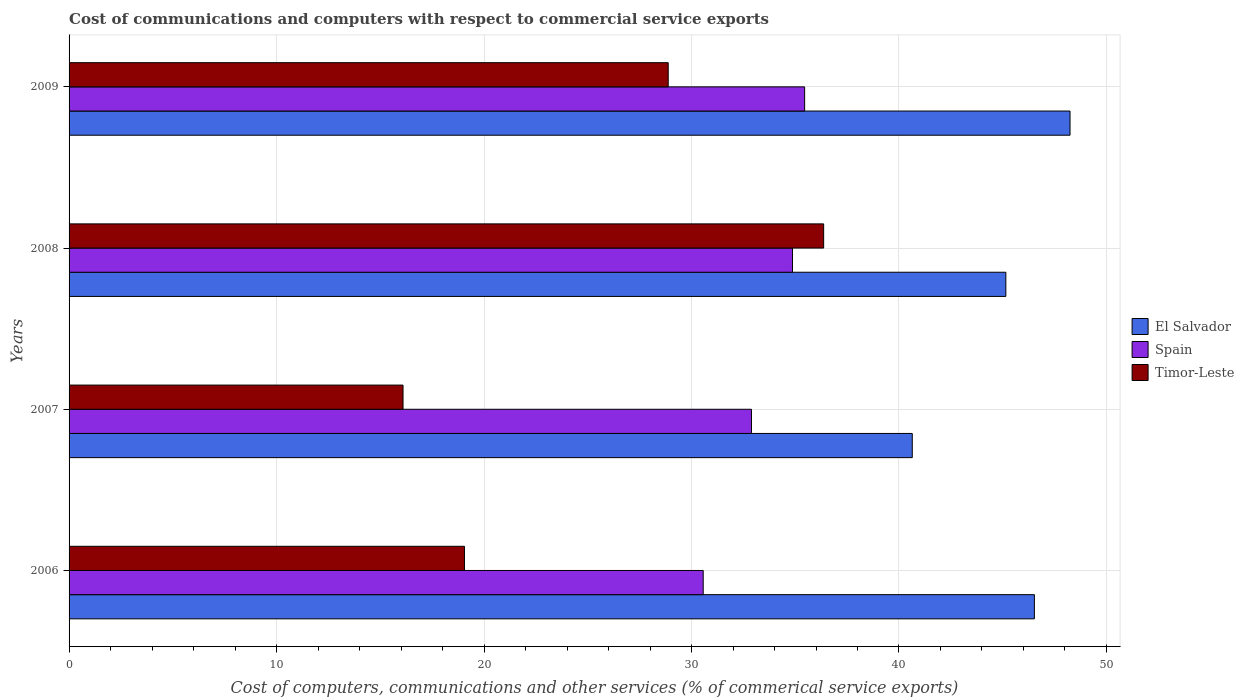Are the number of bars per tick equal to the number of legend labels?
Offer a terse response. Yes. How many bars are there on the 4th tick from the bottom?
Your response must be concise. 3. In how many cases, is the number of bars for a given year not equal to the number of legend labels?
Provide a succinct answer. 0. What is the cost of communications and computers in Spain in 2008?
Provide a short and direct response. 34.87. Across all years, what is the maximum cost of communications and computers in El Salvador?
Offer a very short reply. 48.24. Across all years, what is the minimum cost of communications and computers in Spain?
Offer a terse response. 30.56. In which year was the cost of communications and computers in El Salvador maximum?
Offer a terse response. 2009. In which year was the cost of communications and computers in El Salvador minimum?
Make the answer very short. 2007. What is the total cost of communications and computers in El Salvador in the graph?
Keep it short and to the point. 180.56. What is the difference between the cost of communications and computers in Timor-Leste in 2008 and that in 2009?
Your answer should be very brief. 7.49. What is the difference between the cost of communications and computers in Spain in 2006 and the cost of communications and computers in Timor-Leste in 2007?
Offer a very short reply. 14.47. What is the average cost of communications and computers in El Salvador per year?
Your answer should be very brief. 45.14. In the year 2006, what is the difference between the cost of communications and computers in Spain and cost of communications and computers in Timor-Leste?
Offer a terse response. 11.51. What is the ratio of the cost of communications and computers in Timor-Leste in 2006 to that in 2007?
Give a very brief answer. 1.18. Is the cost of communications and computers in Spain in 2007 less than that in 2008?
Offer a terse response. Yes. Is the difference between the cost of communications and computers in Spain in 2006 and 2008 greater than the difference between the cost of communications and computers in Timor-Leste in 2006 and 2008?
Give a very brief answer. Yes. What is the difference between the highest and the second highest cost of communications and computers in El Salvador?
Provide a short and direct response. 1.72. What is the difference between the highest and the lowest cost of communications and computers in Timor-Leste?
Provide a succinct answer. 20.27. In how many years, is the cost of communications and computers in Spain greater than the average cost of communications and computers in Spain taken over all years?
Provide a succinct answer. 2. What does the 1st bar from the top in 2007 represents?
Provide a succinct answer. Timor-Leste. What does the 1st bar from the bottom in 2009 represents?
Provide a short and direct response. El Salvador. How many bars are there?
Your response must be concise. 12. Are all the bars in the graph horizontal?
Your answer should be compact. Yes. How many years are there in the graph?
Your response must be concise. 4. What is the difference between two consecutive major ticks on the X-axis?
Ensure brevity in your answer.  10. Where does the legend appear in the graph?
Ensure brevity in your answer.  Center right. How many legend labels are there?
Offer a very short reply. 3. What is the title of the graph?
Offer a terse response. Cost of communications and computers with respect to commercial service exports. What is the label or title of the X-axis?
Give a very brief answer. Cost of computers, communications and other services (% of commerical service exports). What is the label or title of the Y-axis?
Keep it short and to the point. Years. What is the Cost of computers, communications and other services (% of commerical service exports) of El Salvador in 2006?
Your answer should be compact. 46.53. What is the Cost of computers, communications and other services (% of commerical service exports) in Spain in 2006?
Your answer should be compact. 30.56. What is the Cost of computers, communications and other services (% of commerical service exports) of Timor-Leste in 2006?
Keep it short and to the point. 19.06. What is the Cost of computers, communications and other services (% of commerical service exports) of El Salvador in 2007?
Keep it short and to the point. 40.64. What is the Cost of computers, communications and other services (% of commerical service exports) in Spain in 2007?
Your answer should be compact. 32.89. What is the Cost of computers, communications and other services (% of commerical service exports) of Timor-Leste in 2007?
Your answer should be very brief. 16.1. What is the Cost of computers, communications and other services (% of commerical service exports) of El Salvador in 2008?
Your answer should be very brief. 45.15. What is the Cost of computers, communications and other services (% of commerical service exports) in Spain in 2008?
Make the answer very short. 34.87. What is the Cost of computers, communications and other services (% of commerical service exports) of Timor-Leste in 2008?
Offer a very short reply. 36.37. What is the Cost of computers, communications and other services (% of commerical service exports) in El Salvador in 2009?
Offer a terse response. 48.24. What is the Cost of computers, communications and other services (% of commerical service exports) in Spain in 2009?
Provide a succinct answer. 35.45. What is the Cost of computers, communications and other services (% of commerical service exports) of Timor-Leste in 2009?
Your answer should be compact. 28.88. Across all years, what is the maximum Cost of computers, communications and other services (% of commerical service exports) of El Salvador?
Give a very brief answer. 48.24. Across all years, what is the maximum Cost of computers, communications and other services (% of commerical service exports) in Spain?
Make the answer very short. 35.45. Across all years, what is the maximum Cost of computers, communications and other services (% of commerical service exports) of Timor-Leste?
Offer a very short reply. 36.37. Across all years, what is the minimum Cost of computers, communications and other services (% of commerical service exports) in El Salvador?
Your answer should be very brief. 40.64. Across all years, what is the minimum Cost of computers, communications and other services (% of commerical service exports) in Spain?
Provide a succinct answer. 30.56. Across all years, what is the minimum Cost of computers, communications and other services (% of commerical service exports) in Timor-Leste?
Offer a terse response. 16.1. What is the total Cost of computers, communications and other services (% of commerical service exports) of El Salvador in the graph?
Ensure brevity in your answer.  180.56. What is the total Cost of computers, communications and other services (% of commerical service exports) of Spain in the graph?
Your answer should be compact. 133.77. What is the total Cost of computers, communications and other services (% of commerical service exports) in Timor-Leste in the graph?
Provide a short and direct response. 100.4. What is the difference between the Cost of computers, communications and other services (% of commerical service exports) of El Salvador in 2006 and that in 2007?
Your response must be concise. 5.89. What is the difference between the Cost of computers, communications and other services (% of commerical service exports) in Spain in 2006 and that in 2007?
Your response must be concise. -2.33. What is the difference between the Cost of computers, communications and other services (% of commerical service exports) of Timor-Leste in 2006 and that in 2007?
Your answer should be very brief. 2.96. What is the difference between the Cost of computers, communications and other services (% of commerical service exports) in El Salvador in 2006 and that in 2008?
Make the answer very short. 1.38. What is the difference between the Cost of computers, communications and other services (% of commerical service exports) of Spain in 2006 and that in 2008?
Provide a succinct answer. -4.3. What is the difference between the Cost of computers, communications and other services (% of commerical service exports) of Timor-Leste in 2006 and that in 2008?
Your answer should be compact. -17.31. What is the difference between the Cost of computers, communications and other services (% of commerical service exports) in El Salvador in 2006 and that in 2009?
Ensure brevity in your answer.  -1.72. What is the difference between the Cost of computers, communications and other services (% of commerical service exports) of Spain in 2006 and that in 2009?
Make the answer very short. -4.89. What is the difference between the Cost of computers, communications and other services (% of commerical service exports) in Timor-Leste in 2006 and that in 2009?
Provide a short and direct response. -9.82. What is the difference between the Cost of computers, communications and other services (% of commerical service exports) of El Salvador in 2007 and that in 2008?
Your answer should be compact. -4.51. What is the difference between the Cost of computers, communications and other services (% of commerical service exports) in Spain in 2007 and that in 2008?
Your response must be concise. -1.98. What is the difference between the Cost of computers, communications and other services (% of commerical service exports) of Timor-Leste in 2007 and that in 2008?
Make the answer very short. -20.27. What is the difference between the Cost of computers, communications and other services (% of commerical service exports) in El Salvador in 2007 and that in 2009?
Offer a terse response. -7.6. What is the difference between the Cost of computers, communications and other services (% of commerical service exports) in Spain in 2007 and that in 2009?
Offer a terse response. -2.56. What is the difference between the Cost of computers, communications and other services (% of commerical service exports) in Timor-Leste in 2007 and that in 2009?
Your answer should be compact. -12.78. What is the difference between the Cost of computers, communications and other services (% of commerical service exports) of El Salvador in 2008 and that in 2009?
Make the answer very short. -3.09. What is the difference between the Cost of computers, communications and other services (% of commerical service exports) of Spain in 2008 and that in 2009?
Give a very brief answer. -0.59. What is the difference between the Cost of computers, communications and other services (% of commerical service exports) of Timor-Leste in 2008 and that in 2009?
Provide a succinct answer. 7.49. What is the difference between the Cost of computers, communications and other services (% of commerical service exports) of El Salvador in 2006 and the Cost of computers, communications and other services (% of commerical service exports) of Spain in 2007?
Give a very brief answer. 13.64. What is the difference between the Cost of computers, communications and other services (% of commerical service exports) of El Salvador in 2006 and the Cost of computers, communications and other services (% of commerical service exports) of Timor-Leste in 2007?
Offer a terse response. 30.43. What is the difference between the Cost of computers, communications and other services (% of commerical service exports) of Spain in 2006 and the Cost of computers, communications and other services (% of commerical service exports) of Timor-Leste in 2007?
Your answer should be compact. 14.47. What is the difference between the Cost of computers, communications and other services (% of commerical service exports) in El Salvador in 2006 and the Cost of computers, communications and other services (% of commerical service exports) in Spain in 2008?
Offer a terse response. 11.66. What is the difference between the Cost of computers, communications and other services (% of commerical service exports) of El Salvador in 2006 and the Cost of computers, communications and other services (% of commerical service exports) of Timor-Leste in 2008?
Offer a terse response. 10.16. What is the difference between the Cost of computers, communications and other services (% of commerical service exports) in Spain in 2006 and the Cost of computers, communications and other services (% of commerical service exports) in Timor-Leste in 2008?
Your answer should be very brief. -5.81. What is the difference between the Cost of computers, communications and other services (% of commerical service exports) of El Salvador in 2006 and the Cost of computers, communications and other services (% of commerical service exports) of Spain in 2009?
Give a very brief answer. 11.07. What is the difference between the Cost of computers, communications and other services (% of commerical service exports) of El Salvador in 2006 and the Cost of computers, communications and other services (% of commerical service exports) of Timor-Leste in 2009?
Give a very brief answer. 17.65. What is the difference between the Cost of computers, communications and other services (% of commerical service exports) in Spain in 2006 and the Cost of computers, communications and other services (% of commerical service exports) in Timor-Leste in 2009?
Your answer should be compact. 1.69. What is the difference between the Cost of computers, communications and other services (% of commerical service exports) of El Salvador in 2007 and the Cost of computers, communications and other services (% of commerical service exports) of Spain in 2008?
Your answer should be compact. 5.77. What is the difference between the Cost of computers, communications and other services (% of commerical service exports) of El Salvador in 2007 and the Cost of computers, communications and other services (% of commerical service exports) of Timor-Leste in 2008?
Your response must be concise. 4.27. What is the difference between the Cost of computers, communications and other services (% of commerical service exports) of Spain in 2007 and the Cost of computers, communications and other services (% of commerical service exports) of Timor-Leste in 2008?
Ensure brevity in your answer.  -3.48. What is the difference between the Cost of computers, communications and other services (% of commerical service exports) in El Salvador in 2007 and the Cost of computers, communications and other services (% of commerical service exports) in Spain in 2009?
Offer a terse response. 5.19. What is the difference between the Cost of computers, communications and other services (% of commerical service exports) in El Salvador in 2007 and the Cost of computers, communications and other services (% of commerical service exports) in Timor-Leste in 2009?
Your answer should be compact. 11.76. What is the difference between the Cost of computers, communications and other services (% of commerical service exports) of Spain in 2007 and the Cost of computers, communications and other services (% of commerical service exports) of Timor-Leste in 2009?
Provide a short and direct response. 4.01. What is the difference between the Cost of computers, communications and other services (% of commerical service exports) in El Salvador in 2008 and the Cost of computers, communications and other services (% of commerical service exports) in Spain in 2009?
Give a very brief answer. 9.7. What is the difference between the Cost of computers, communications and other services (% of commerical service exports) of El Salvador in 2008 and the Cost of computers, communications and other services (% of commerical service exports) of Timor-Leste in 2009?
Your answer should be compact. 16.27. What is the difference between the Cost of computers, communications and other services (% of commerical service exports) in Spain in 2008 and the Cost of computers, communications and other services (% of commerical service exports) in Timor-Leste in 2009?
Offer a terse response. 5.99. What is the average Cost of computers, communications and other services (% of commerical service exports) of El Salvador per year?
Give a very brief answer. 45.14. What is the average Cost of computers, communications and other services (% of commerical service exports) in Spain per year?
Your answer should be very brief. 33.44. What is the average Cost of computers, communications and other services (% of commerical service exports) in Timor-Leste per year?
Provide a short and direct response. 25.1. In the year 2006, what is the difference between the Cost of computers, communications and other services (% of commerical service exports) of El Salvador and Cost of computers, communications and other services (% of commerical service exports) of Spain?
Provide a short and direct response. 15.96. In the year 2006, what is the difference between the Cost of computers, communications and other services (% of commerical service exports) in El Salvador and Cost of computers, communications and other services (% of commerical service exports) in Timor-Leste?
Your answer should be compact. 27.47. In the year 2006, what is the difference between the Cost of computers, communications and other services (% of commerical service exports) in Spain and Cost of computers, communications and other services (% of commerical service exports) in Timor-Leste?
Keep it short and to the point. 11.51. In the year 2007, what is the difference between the Cost of computers, communications and other services (% of commerical service exports) of El Salvador and Cost of computers, communications and other services (% of commerical service exports) of Spain?
Your answer should be very brief. 7.75. In the year 2007, what is the difference between the Cost of computers, communications and other services (% of commerical service exports) in El Salvador and Cost of computers, communications and other services (% of commerical service exports) in Timor-Leste?
Offer a very short reply. 24.54. In the year 2007, what is the difference between the Cost of computers, communications and other services (% of commerical service exports) in Spain and Cost of computers, communications and other services (% of commerical service exports) in Timor-Leste?
Make the answer very short. 16.79. In the year 2008, what is the difference between the Cost of computers, communications and other services (% of commerical service exports) in El Salvador and Cost of computers, communications and other services (% of commerical service exports) in Spain?
Provide a short and direct response. 10.28. In the year 2008, what is the difference between the Cost of computers, communications and other services (% of commerical service exports) in El Salvador and Cost of computers, communications and other services (% of commerical service exports) in Timor-Leste?
Provide a succinct answer. 8.78. In the year 2008, what is the difference between the Cost of computers, communications and other services (% of commerical service exports) of Spain and Cost of computers, communications and other services (% of commerical service exports) of Timor-Leste?
Your answer should be compact. -1.5. In the year 2009, what is the difference between the Cost of computers, communications and other services (% of commerical service exports) of El Salvador and Cost of computers, communications and other services (% of commerical service exports) of Spain?
Provide a succinct answer. 12.79. In the year 2009, what is the difference between the Cost of computers, communications and other services (% of commerical service exports) in El Salvador and Cost of computers, communications and other services (% of commerical service exports) in Timor-Leste?
Offer a very short reply. 19.37. In the year 2009, what is the difference between the Cost of computers, communications and other services (% of commerical service exports) of Spain and Cost of computers, communications and other services (% of commerical service exports) of Timor-Leste?
Your answer should be compact. 6.58. What is the ratio of the Cost of computers, communications and other services (% of commerical service exports) of El Salvador in 2006 to that in 2007?
Offer a terse response. 1.14. What is the ratio of the Cost of computers, communications and other services (% of commerical service exports) of Spain in 2006 to that in 2007?
Your response must be concise. 0.93. What is the ratio of the Cost of computers, communications and other services (% of commerical service exports) of Timor-Leste in 2006 to that in 2007?
Offer a very short reply. 1.18. What is the ratio of the Cost of computers, communications and other services (% of commerical service exports) of El Salvador in 2006 to that in 2008?
Offer a very short reply. 1.03. What is the ratio of the Cost of computers, communications and other services (% of commerical service exports) in Spain in 2006 to that in 2008?
Provide a short and direct response. 0.88. What is the ratio of the Cost of computers, communications and other services (% of commerical service exports) of Timor-Leste in 2006 to that in 2008?
Keep it short and to the point. 0.52. What is the ratio of the Cost of computers, communications and other services (% of commerical service exports) in El Salvador in 2006 to that in 2009?
Your answer should be compact. 0.96. What is the ratio of the Cost of computers, communications and other services (% of commerical service exports) in Spain in 2006 to that in 2009?
Ensure brevity in your answer.  0.86. What is the ratio of the Cost of computers, communications and other services (% of commerical service exports) of Timor-Leste in 2006 to that in 2009?
Provide a short and direct response. 0.66. What is the ratio of the Cost of computers, communications and other services (% of commerical service exports) in El Salvador in 2007 to that in 2008?
Offer a very short reply. 0.9. What is the ratio of the Cost of computers, communications and other services (% of commerical service exports) in Spain in 2007 to that in 2008?
Keep it short and to the point. 0.94. What is the ratio of the Cost of computers, communications and other services (% of commerical service exports) of Timor-Leste in 2007 to that in 2008?
Your answer should be very brief. 0.44. What is the ratio of the Cost of computers, communications and other services (% of commerical service exports) in El Salvador in 2007 to that in 2009?
Offer a very short reply. 0.84. What is the ratio of the Cost of computers, communications and other services (% of commerical service exports) of Spain in 2007 to that in 2009?
Make the answer very short. 0.93. What is the ratio of the Cost of computers, communications and other services (% of commerical service exports) in Timor-Leste in 2007 to that in 2009?
Your answer should be compact. 0.56. What is the ratio of the Cost of computers, communications and other services (% of commerical service exports) of El Salvador in 2008 to that in 2009?
Give a very brief answer. 0.94. What is the ratio of the Cost of computers, communications and other services (% of commerical service exports) of Spain in 2008 to that in 2009?
Your answer should be compact. 0.98. What is the ratio of the Cost of computers, communications and other services (% of commerical service exports) of Timor-Leste in 2008 to that in 2009?
Provide a short and direct response. 1.26. What is the difference between the highest and the second highest Cost of computers, communications and other services (% of commerical service exports) of El Salvador?
Make the answer very short. 1.72. What is the difference between the highest and the second highest Cost of computers, communications and other services (% of commerical service exports) of Spain?
Your answer should be compact. 0.59. What is the difference between the highest and the second highest Cost of computers, communications and other services (% of commerical service exports) in Timor-Leste?
Your response must be concise. 7.49. What is the difference between the highest and the lowest Cost of computers, communications and other services (% of commerical service exports) of El Salvador?
Offer a terse response. 7.6. What is the difference between the highest and the lowest Cost of computers, communications and other services (% of commerical service exports) of Spain?
Offer a very short reply. 4.89. What is the difference between the highest and the lowest Cost of computers, communications and other services (% of commerical service exports) of Timor-Leste?
Ensure brevity in your answer.  20.27. 